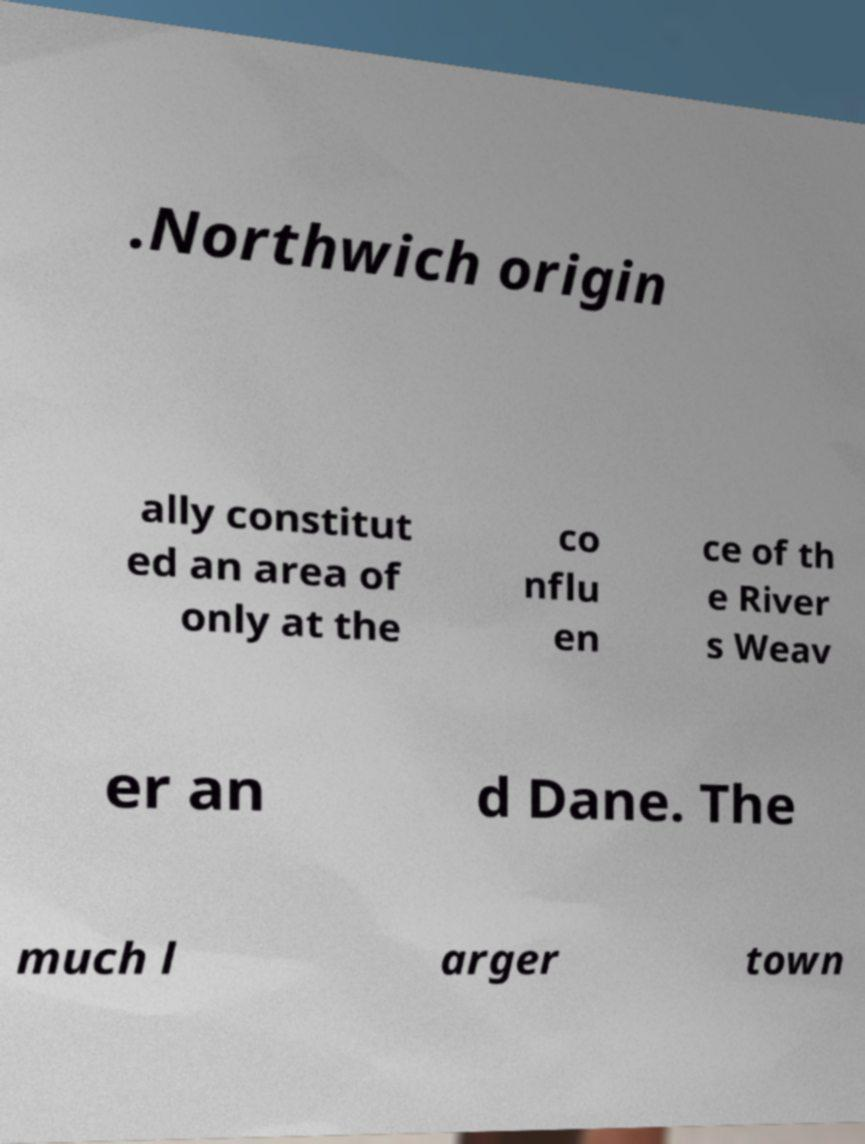Could you extract and type out the text from this image? .Northwich origin ally constitut ed an area of only at the co nflu en ce of th e River s Weav er an d Dane. The much l arger town 